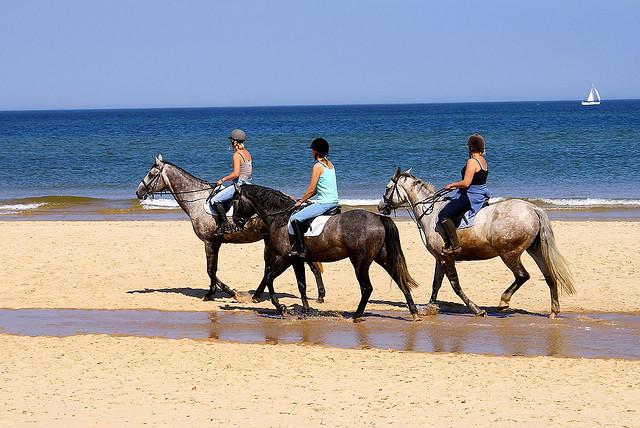How many horses are on the beach?
Keep it brief. 3. Is the sky clear?
Write a very short answer. Yes. What's floating on the water?
Be succinct. Boat. 